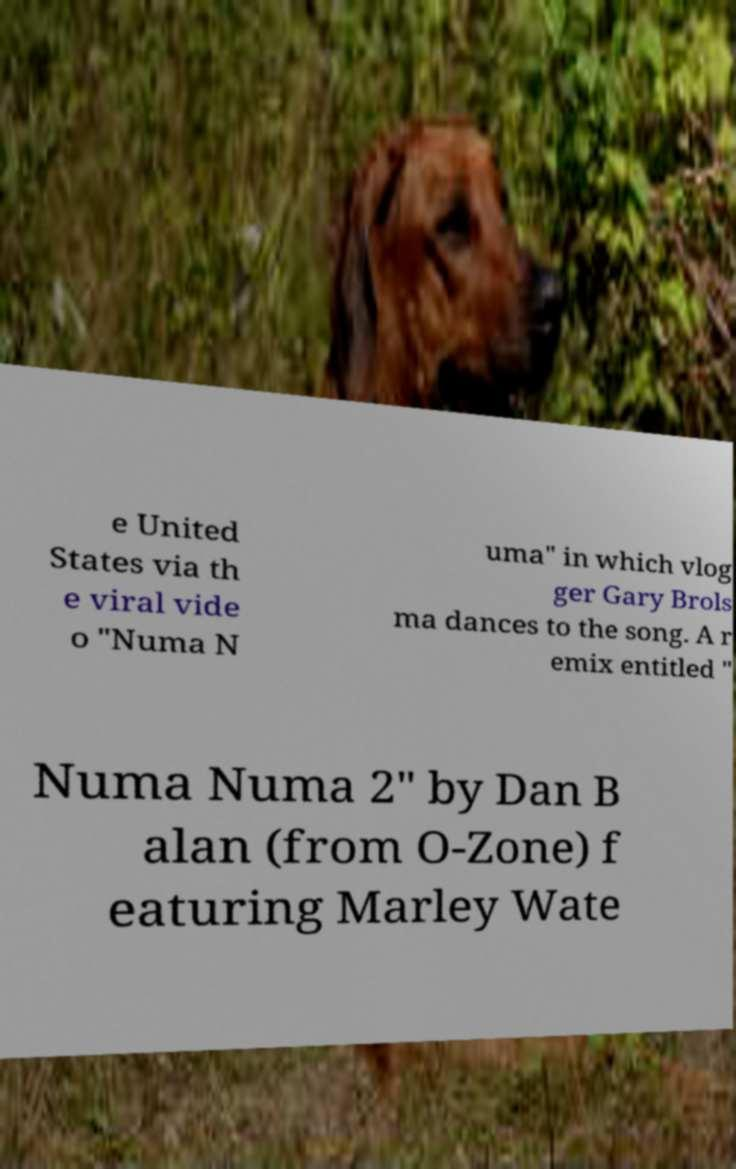For documentation purposes, I need the text within this image transcribed. Could you provide that? e United States via th e viral vide o "Numa N uma" in which vlog ger Gary Brols ma dances to the song. A r emix entitled " Numa Numa 2" by Dan B alan (from O-Zone) f eaturing Marley Wate 